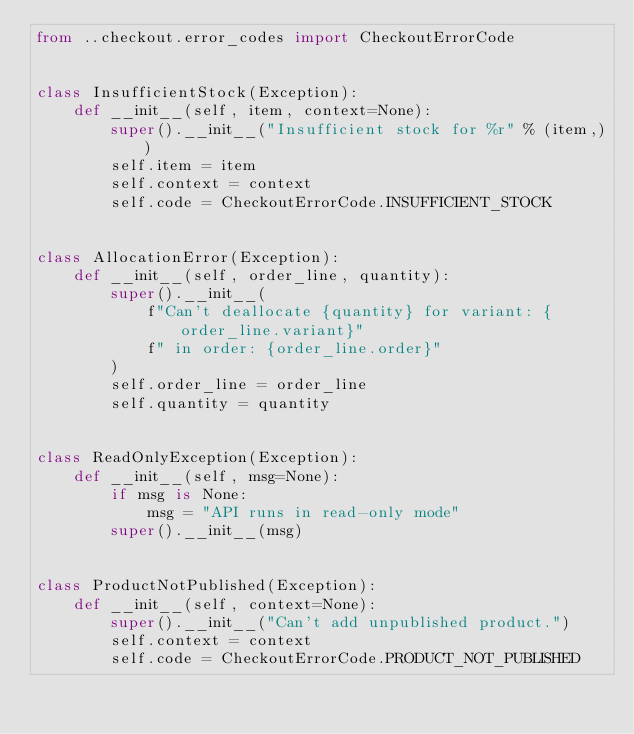<code> <loc_0><loc_0><loc_500><loc_500><_Python_>from ..checkout.error_codes import CheckoutErrorCode


class InsufficientStock(Exception):
    def __init__(self, item, context=None):
        super().__init__("Insufficient stock for %r" % (item,))
        self.item = item
        self.context = context
        self.code = CheckoutErrorCode.INSUFFICIENT_STOCK


class AllocationError(Exception):
    def __init__(self, order_line, quantity):
        super().__init__(
            f"Can't deallocate {quantity} for variant: {order_line.variant}"
            f" in order: {order_line.order}"
        )
        self.order_line = order_line
        self.quantity = quantity


class ReadOnlyException(Exception):
    def __init__(self, msg=None):
        if msg is None:
            msg = "API runs in read-only mode"
        super().__init__(msg)


class ProductNotPublished(Exception):
    def __init__(self, context=None):
        super().__init__("Can't add unpublished product.")
        self.context = context
        self.code = CheckoutErrorCode.PRODUCT_NOT_PUBLISHED
</code> 